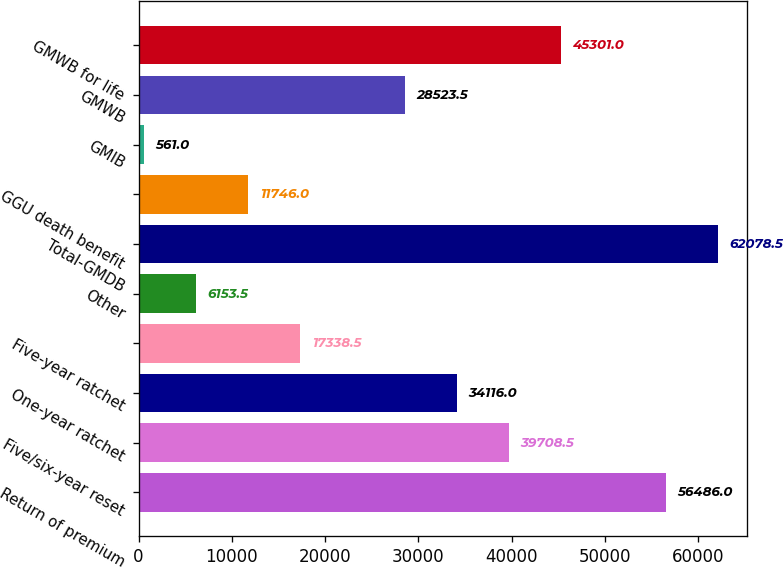Convert chart to OTSL. <chart><loc_0><loc_0><loc_500><loc_500><bar_chart><fcel>Return of premium<fcel>Five/six-year reset<fcel>One-year ratchet<fcel>Five-year ratchet<fcel>Other<fcel>Total-GMDB<fcel>GGU death benefit<fcel>GMIB<fcel>GMWB<fcel>GMWB for life<nl><fcel>56486<fcel>39708.5<fcel>34116<fcel>17338.5<fcel>6153.5<fcel>62078.5<fcel>11746<fcel>561<fcel>28523.5<fcel>45301<nl></chart> 